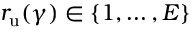Convert formula to latex. <formula><loc_0><loc_0><loc_500><loc_500>r _ { u } ( \gamma ) \in \left \{ 1 , \dots , E \right \}</formula> 